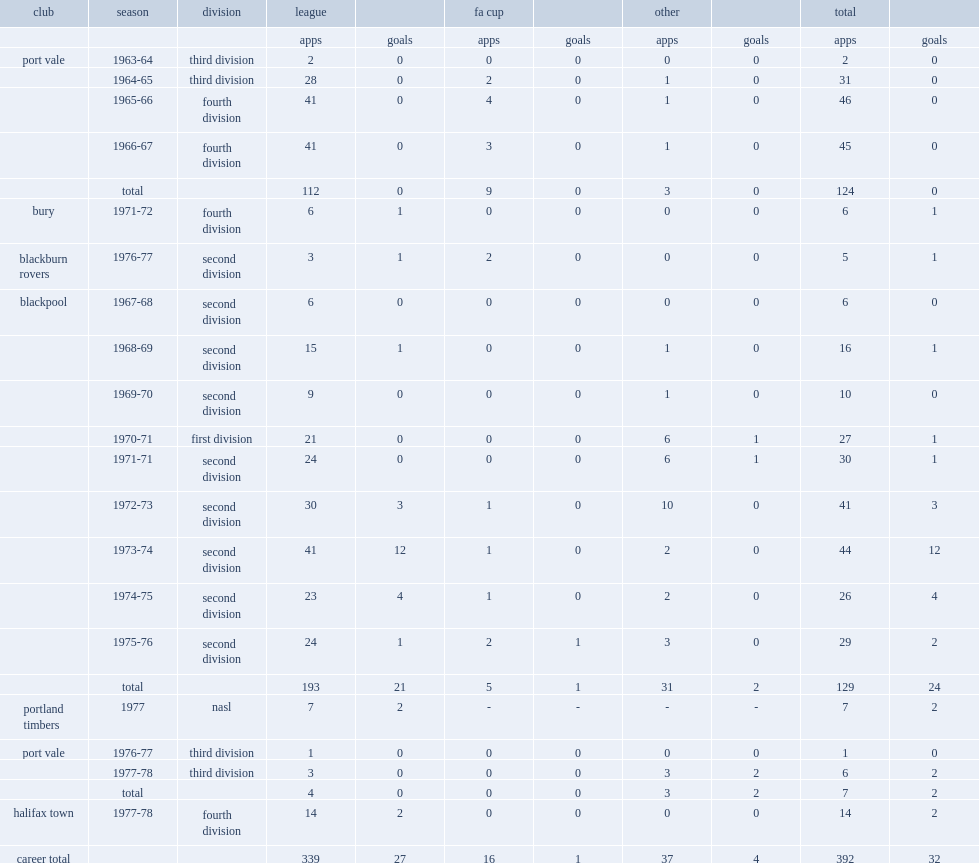How many league appearances did terry alcock make for port vale? 112.0. 